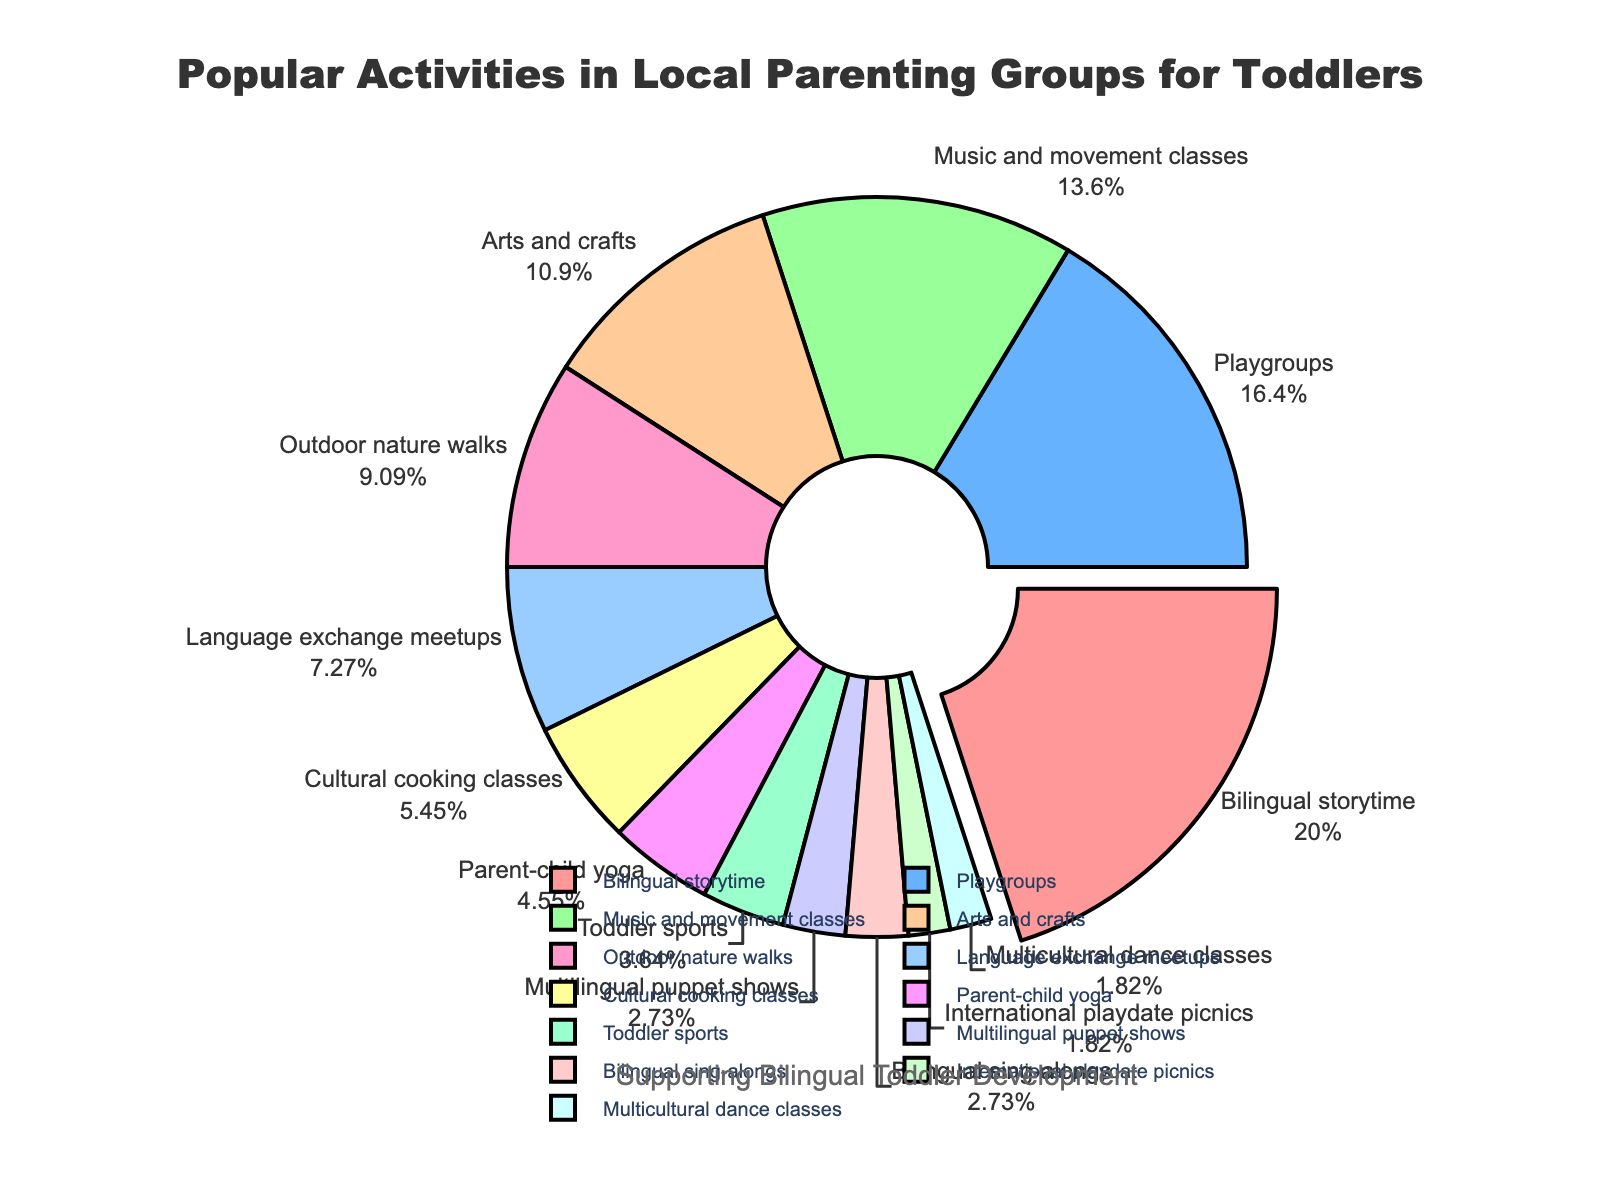Which activity has the highest percentage? The activity with the highest percentage will be the one where the slice is pulled out from the pie chart. This is the "Bilingual storytime" with 22%.
Answer: Bilingual storytime How much greater is the percentage of Bilingual storytime compared to Playgroups? Bilingual storytime has 22% and Playgroups has 18%. The difference is 22 - 18 = 4%.
Answer: 4% What is the combined percentage of Music and movement classes, Arts and crafts, and Outdoor nature walks? Adding the percentages: 15% (Music and movement) + 12% (Arts and crafts) + 10% (Outdoor nature walks) = 37%.
Answer: 37% Which activities have percentages less than 5%? By looking at the slices with small percentages, we see these are Parent-child yoga, Toddler sports, Multilingual puppet shows, Bilingual sing-alongs, International playdate picnics, and Multicultural dance classes.
Answer: Parent-child yoga, Toddler sports, Multilingual puppet shows, Bilingual sing-alongs, International playdate picnics, Multicultural dance classes What is the average percentage of activities categorized under bilingual and cultural activities? Bilingual and cultural activities are Bilingual storytime (22%), Language exchange meetups (8%), Cultural cooking classes (6%), Multilingual puppet shows (3%), Bilingual sing-alongs (3%), and Multicultural dance classes (2%). Summing these gives 22 + 8 + 6 + 3 + 3 + 2 = 44%. There are 6 activities, so the average is 44 / 6 = 7.33%.
Answer: 7.33% Which activity is represented by the light green slice? By looking at the colors, the light green slice corresponds to Playgroups which have a percentage of 18%.
Answer: Playgroups How much greater is the percentage of Bilingual storytime compared to all activities combined that are below 5%? Bilingual storytime is 22%. Activities below 5% are: Parent-child yoga (5%) + Toddler sports (4%) + Multilingual puppet shows (3%) + Bilingual sing-alongs (3%) + International playdate picnics (2%) + Multicultural dance classes (2%) = 19%. The difference is 22 - 19 = 3%.
Answer: 3% Which slice is positioned after the largest slice when the pie chart is viewed clockwise? Immediately after the largest slice (Bilingual storytime), moving clockwise, is the Playgroups slice (18%).
Answer: Playgroups How many activities make up more than 10% each? These are Bilingual storytime (22%), Playgroups (18%), Music and movement classes (15%), and Arts and crafts (12%). There are 4 such activities.
Answer: 4 